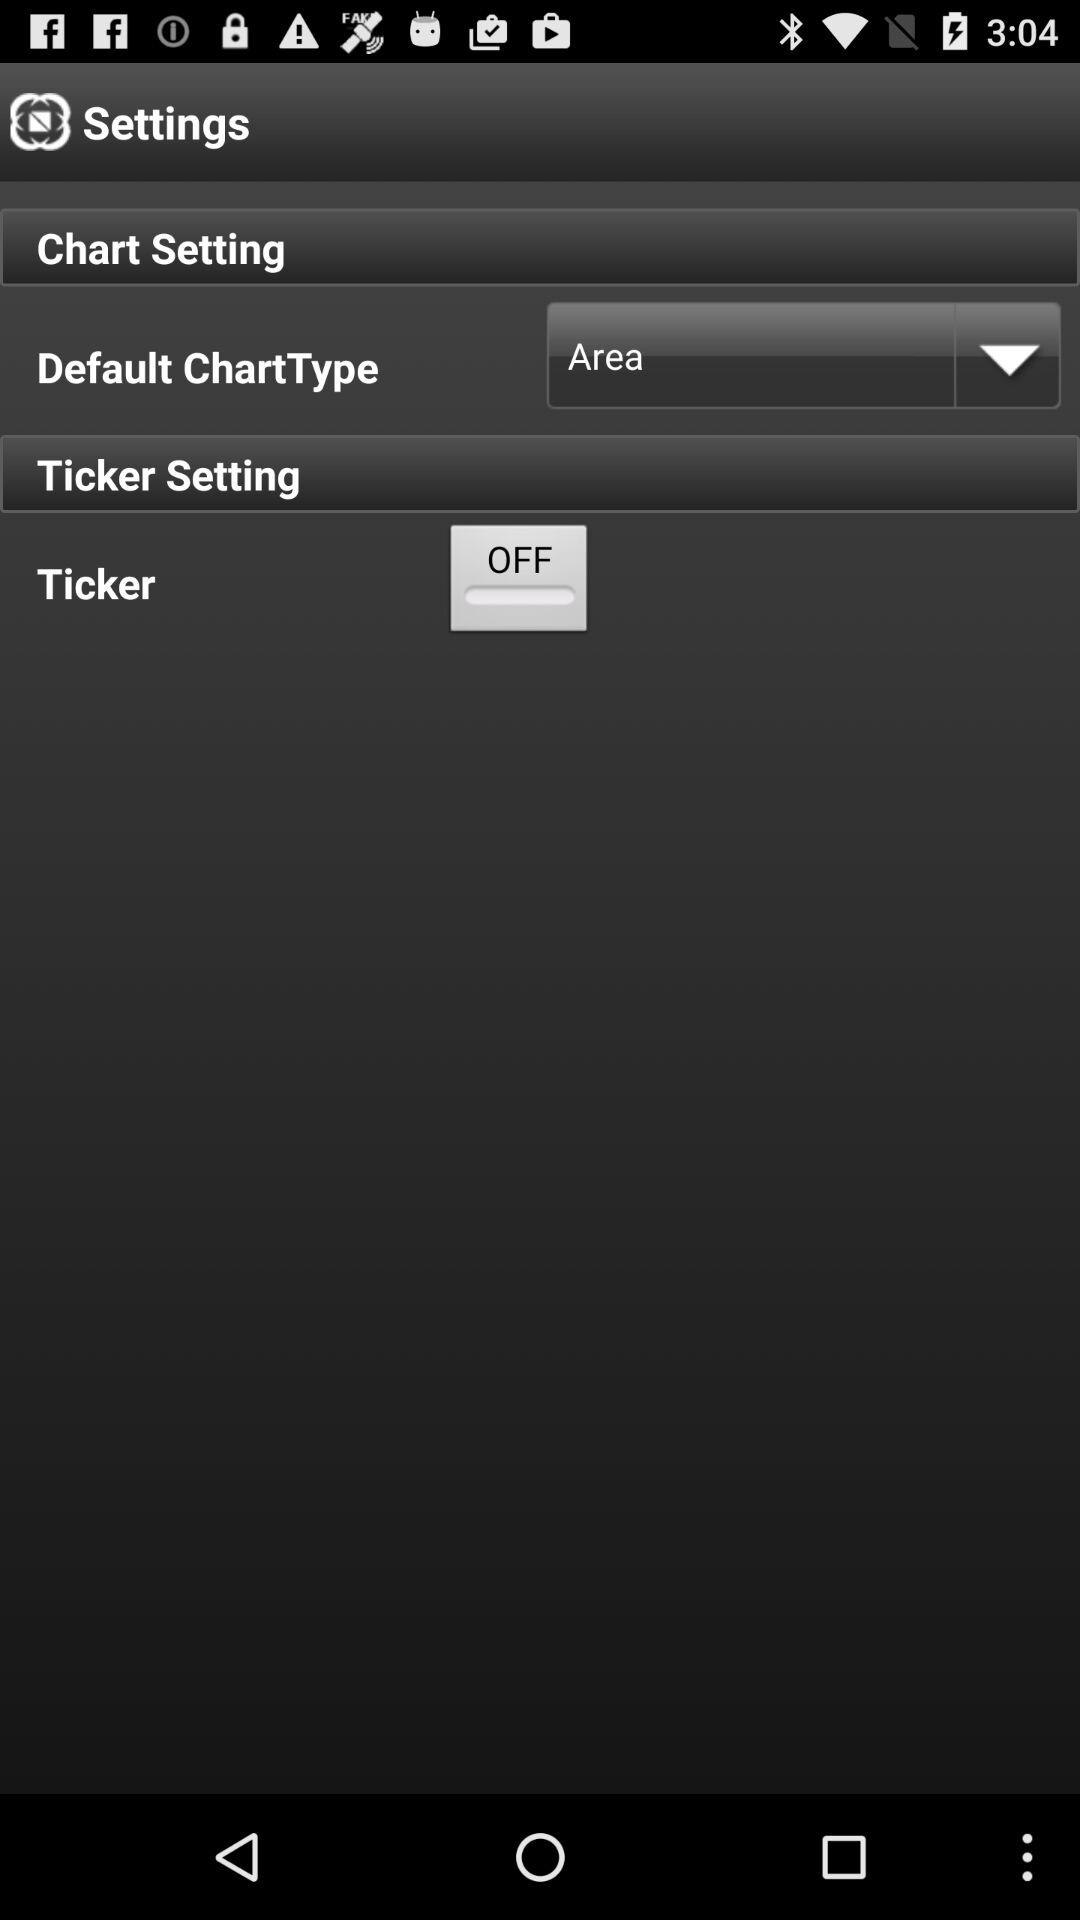Which is the setting for the "Default ChartType"? The setting is "Area". 